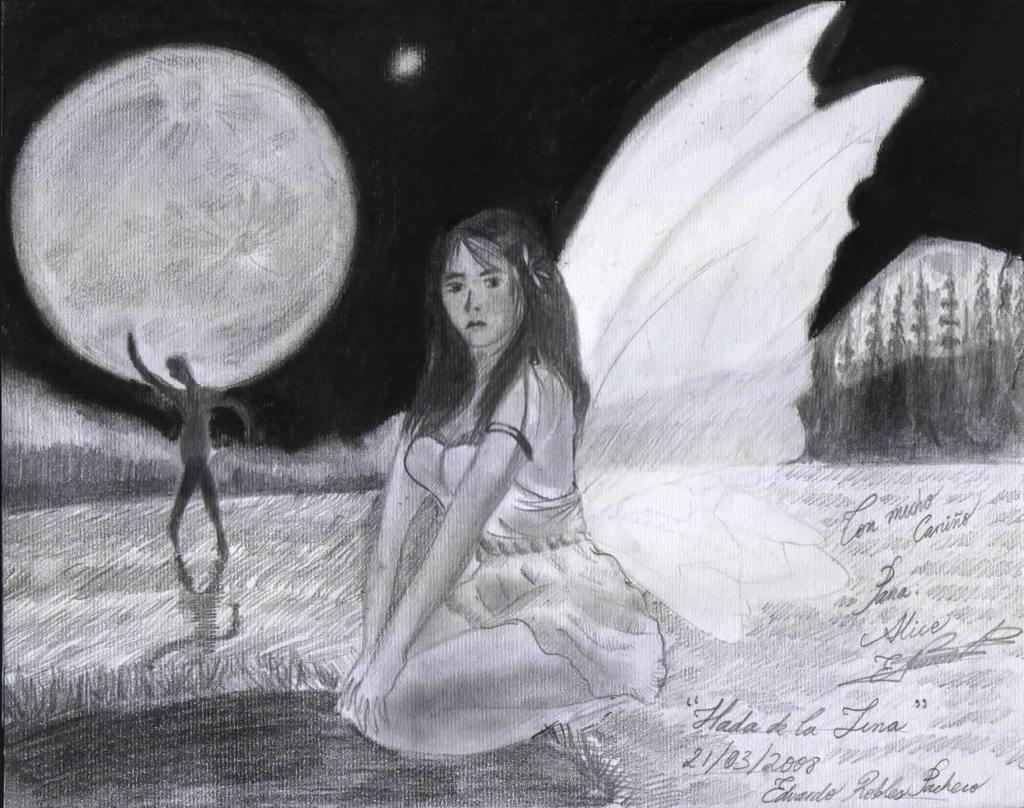What type of artwork is depicted in the image? The image is a sketch. Who or what is the main subject of the sketch? There is a beautiful woman in the sketch. What distinguishing feature does the woman have? The woman has white color wings. What can be seen on the left side of the sketch? There is a man structure on the left side of the sketch. What type of meat is being sold on the street in the sketch? There is no street or meat present in the sketch; it is a sketch of a woman with wings and a man structure on the left side. 